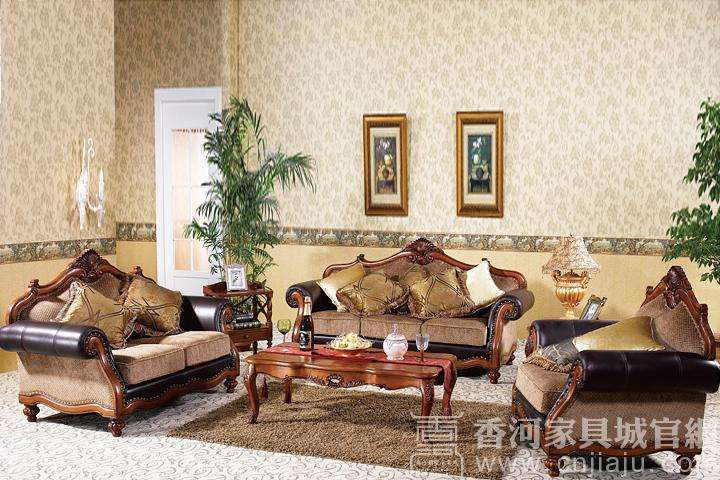How many sofas would there be in the image now that two more sofas have been moved into the scene? There are currently three sofas in the image. With the addition of two more sofas, there would be a total of five sofas in the scene. Arranging five sofas in a room would create a cozy and inviting atmosphere, offering plenty of seating for guests or family members. It would be important to consider the layout to maintain an uncluttered and harmonious space. 